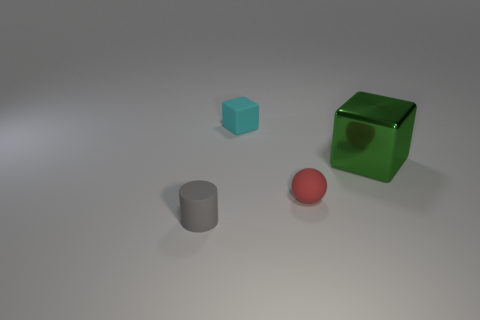Add 3 large red spheres. How many objects exist? 7 Subtract all spheres. How many objects are left? 3 Subtract 0 purple blocks. How many objects are left? 4 Subtract all big things. Subtract all small red matte objects. How many objects are left? 2 Add 2 tiny gray matte things. How many tiny gray matte things are left? 3 Add 4 purple spheres. How many purple spheres exist? 4 